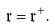Convert formula to latex. <formula><loc_0><loc_0><loc_500><loc_500>\mathfrak r = \mathfrak r ^ { + } .</formula> 